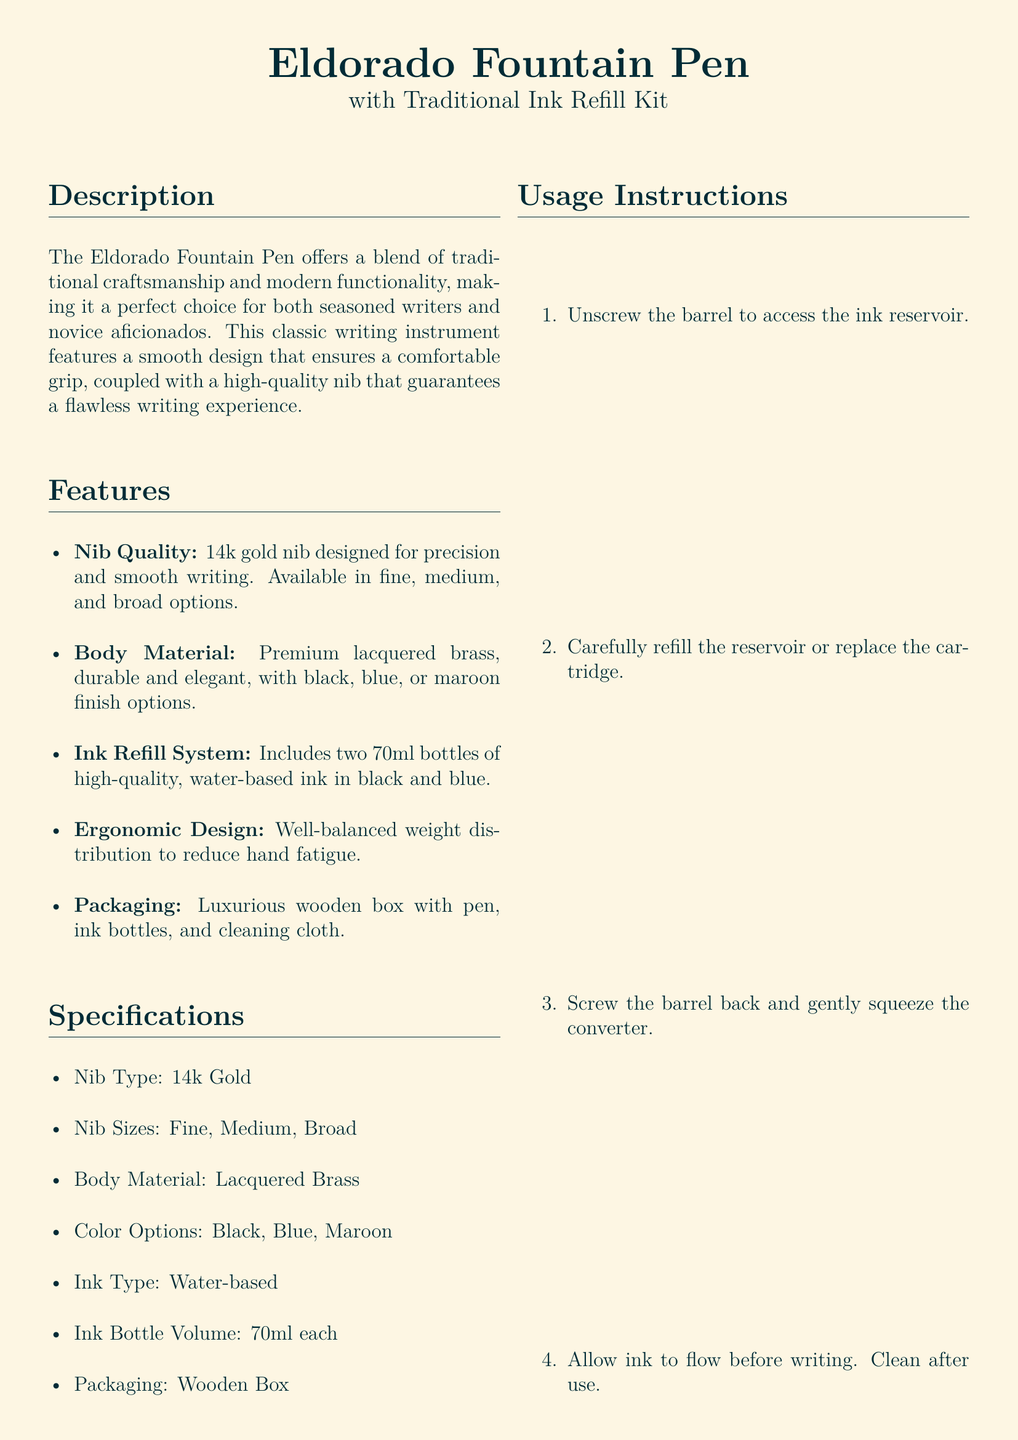What is the name of the fountain pen? The name of the fountain pen is mentioned in the title of the document, which is "Eldorado Fountain Pen."
Answer: Eldorado Fountain Pen What materials are used for the body of the pen? The body material is specified in the document, mentioning "Premium lacquered brass."
Answer: Premium lacquered brass What colors are available for the fountain pen? The document lists the color options under the specifications section, which are black, blue, and maroon.
Answer: Black, Blue, Maroon What is the ink type provided in the refill kit? The ink type is specified as "water-based" in the specifications section of the document.
Answer: Water-based How many ink bottles are included in the kit? The document states that the kit includes two 70ml bottles of ink.
Answer: Two What size options are available for the nib? The document indicates the nib sizes available, which are fine, medium, and broad.
Answer: Fine, Medium, Broad What is included in the packaging of the product? The last point under the features describes that it comes in a "Luxurious wooden box with pen, ink bottles, and cleaning cloth."
Answer: Luxurious wooden box Who is the manufacturer of the fountain pen? The document clearly mentions the manufacturer as "Eldorado Writing Instruments Co."
Answer: Eldorado Writing Instruments Co What is the price of the fountain pen? The price is clearly stated at the end of the document as "$150."
Answer: $150 